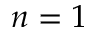<formula> <loc_0><loc_0><loc_500><loc_500>n = 1</formula> 